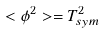<formula> <loc_0><loc_0><loc_500><loc_500>< \phi ^ { 2 } > = T _ { s y m } ^ { 2 }</formula> 